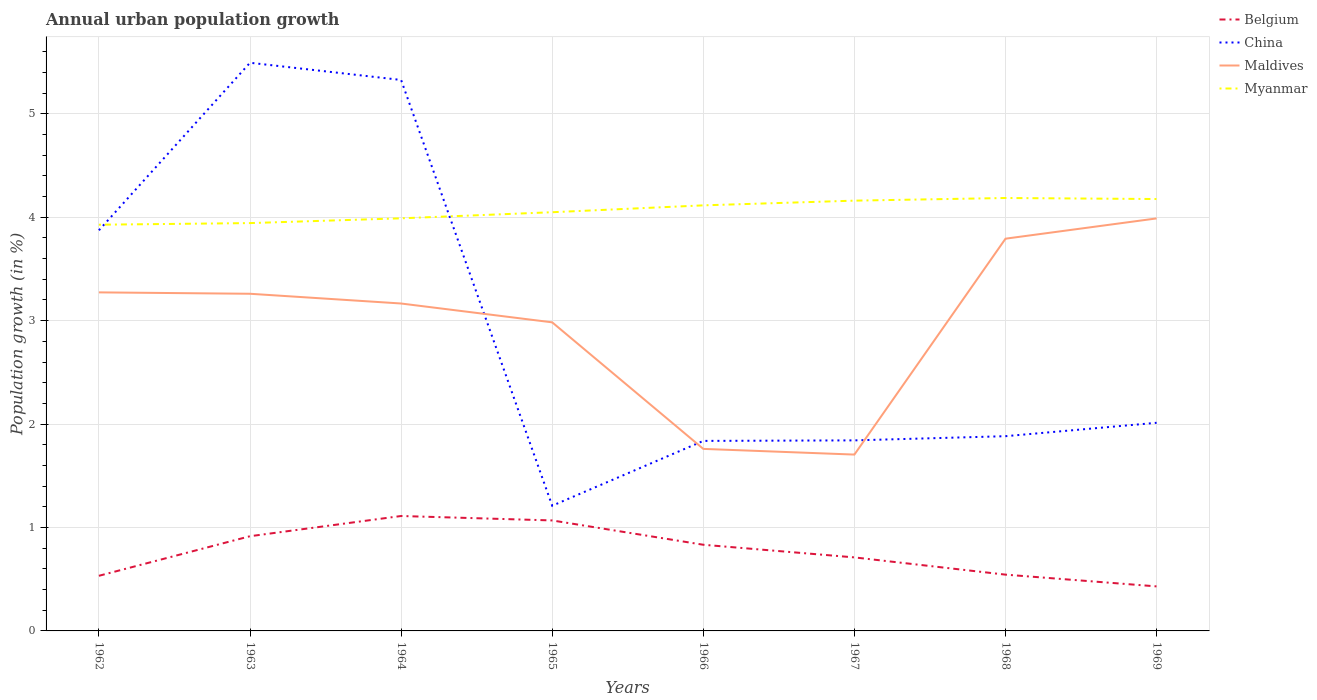Is the number of lines equal to the number of legend labels?
Keep it short and to the point. Yes. Across all years, what is the maximum percentage of urban population growth in Belgium?
Ensure brevity in your answer.  0.43. What is the total percentage of urban population growth in China in the graph?
Offer a terse response. 2.66. What is the difference between the highest and the second highest percentage of urban population growth in Belgium?
Give a very brief answer. 0.68. What is the difference between the highest and the lowest percentage of urban population growth in Belgium?
Offer a terse response. 4. How many years are there in the graph?
Make the answer very short. 8. Are the values on the major ticks of Y-axis written in scientific E-notation?
Your answer should be very brief. No. Does the graph contain any zero values?
Ensure brevity in your answer.  No. Does the graph contain grids?
Keep it short and to the point. Yes. What is the title of the graph?
Provide a succinct answer. Annual urban population growth. What is the label or title of the X-axis?
Provide a short and direct response. Years. What is the label or title of the Y-axis?
Your answer should be compact. Population growth (in %). What is the Population growth (in %) in Belgium in 1962?
Ensure brevity in your answer.  0.53. What is the Population growth (in %) of China in 1962?
Give a very brief answer. 3.87. What is the Population growth (in %) of Maldives in 1962?
Keep it short and to the point. 3.27. What is the Population growth (in %) in Myanmar in 1962?
Offer a terse response. 3.93. What is the Population growth (in %) of Belgium in 1963?
Offer a very short reply. 0.92. What is the Population growth (in %) of China in 1963?
Offer a terse response. 5.49. What is the Population growth (in %) in Maldives in 1963?
Provide a succinct answer. 3.26. What is the Population growth (in %) in Myanmar in 1963?
Your answer should be very brief. 3.94. What is the Population growth (in %) in Belgium in 1964?
Ensure brevity in your answer.  1.11. What is the Population growth (in %) of China in 1964?
Provide a short and direct response. 5.33. What is the Population growth (in %) of Maldives in 1964?
Give a very brief answer. 3.17. What is the Population growth (in %) in Myanmar in 1964?
Offer a terse response. 3.99. What is the Population growth (in %) of Belgium in 1965?
Provide a succinct answer. 1.07. What is the Population growth (in %) of China in 1965?
Provide a succinct answer. 1.21. What is the Population growth (in %) in Maldives in 1965?
Give a very brief answer. 2.98. What is the Population growth (in %) of Myanmar in 1965?
Your response must be concise. 4.05. What is the Population growth (in %) in Belgium in 1966?
Ensure brevity in your answer.  0.83. What is the Population growth (in %) of China in 1966?
Offer a very short reply. 1.84. What is the Population growth (in %) in Maldives in 1966?
Your response must be concise. 1.76. What is the Population growth (in %) of Myanmar in 1966?
Provide a short and direct response. 4.11. What is the Population growth (in %) in Belgium in 1967?
Give a very brief answer. 0.71. What is the Population growth (in %) in China in 1967?
Your response must be concise. 1.84. What is the Population growth (in %) in Maldives in 1967?
Give a very brief answer. 1.71. What is the Population growth (in %) in Myanmar in 1967?
Ensure brevity in your answer.  4.16. What is the Population growth (in %) in Belgium in 1968?
Keep it short and to the point. 0.54. What is the Population growth (in %) in China in 1968?
Give a very brief answer. 1.88. What is the Population growth (in %) of Maldives in 1968?
Make the answer very short. 3.79. What is the Population growth (in %) in Myanmar in 1968?
Give a very brief answer. 4.19. What is the Population growth (in %) in Belgium in 1969?
Offer a terse response. 0.43. What is the Population growth (in %) of China in 1969?
Provide a succinct answer. 2.01. What is the Population growth (in %) of Maldives in 1969?
Make the answer very short. 3.99. What is the Population growth (in %) in Myanmar in 1969?
Your answer should be very brief. 4.18. Across all years, what is the maximum Population growth (in %) in Belgium?
Ensure brevity in your answer.  1.11. Across all years, what is the maximum Population growth (in %) of China?
Keep it short and to the point. 5.49. Across all years, what is the maximum Population growth (in %) of Maldives?
Provide a short and direct response. 3.99. Across all years, what is the maximum Population growth (in %) in Myanmar?
Give a very brief answer. 4.19. Across all years, what is the minimum Population growth (in %) of Belgium?
Keep it short and to the point. 0.43. Across all years, what is the minimum Population growth (in %) in China?
Keep it short and to the point. 1.21. Across all years, what is the minimum Population growth (in %) in Maldives?
Your response must be concise. 1.71. Across all years, what is the minimum Population growth (in %) of Myanmar?
Offer a terse response. 3.93. What is the total Population growth (in %) of Belgium in the graph?
Your answer should be very brief. 6.15. What is the total Population growth (in %) in China in the graph?
Keep it short and to the point. 23.48. What is the total Population growth (in %) in Maldives in the graph?
Make the answer very short. 23.93. What is the total Population growth (in %) of Myanmar in the graph?
Your response must be concise. 32.55. What is the difference between the Population growth (in %) in Belgium in 1962 and that in 1963?
Offer a very short reply. -0.38. What is the difference between the Population growth (in %) of China in 1962 and that in 1963?
Offer a very short reply. -1.62. What is the difference between the Population growth (in %) of Maldives in 1962 and that in 1963?
Keep it short and to the point. 0.01. What is the difference between the Population growth (in %) in Myanmar in 1962 and that in 1963?
Provide a short and direct response. -0.02. What is the difference between the Population growth (in %) of Belgium in 1962 and that in 1964?
Provide a succinct answer. -0.58. What is the difference between the Population growth (in %) of China in 1962 and that in 1964?
Offer a very short reply. -1.45. What is the difference between the Population growth (in %) in Maldives in 1962 and that in 1964?
Your response must be concise. 0.11. What is the difference between the Population growth (in %) of Myanmar in 1962 and that in 1964?
Keep it short and to the point. -0.06. What is the difference between the Population growth (in %) of Belgium in 1962 and that in 1965?
Your answer should be compact. -0.54. What is the difference between the Population growth (in %) in China in 1962 and that in 1965?
Give a very brief answer. 2.66. What is the difference between the Population growth (in %) of Maldives in 1962 and that in 1965?
Offer a terse response. 0.29. What is the difference between the Population growth (in %) in Myanmar in 1962 and that in 1965?
Your response must be concise. -0.12. What is the difference between the Population growth (in %) in Belgium in 1962 and that in 1966?
Offer a very short reply. -0.3. What is the difference between the Population growth (in %) in China in 1962 and that in 1966?
Provide a succinct answer. 2.04. What is the difference between the Population growth (in %) in Maldives in 1962 and that in 1966?
Ensure brevity in your answer.  1.51. What is the difference between the Population growth (in %) in Myanmar in 1962 and that in 1966?
Make the answer very short. -0.19. What is the difference between the Population growth (in %) in Belgium in 1962 and that in 1967?
Offer a very short reply. -0.18. What is the difference between the Population growth (in %) in China in 1962 and that in 1967?
Give a very brief answer. 2.03. What is the difference between the Population growth (in %) in Maldives in 1962 and that in 1967?
Your answer should be compact. 1.57. What is the difference between the Population growth (in %) of Myanmar in 1962 and that in 1967?
Provide a succinct answer. -0.23. What is the difference between the Population growth (in %) of Belgium in 1962 and that in 1968?
Provide a short and direct response. -0.01. What is the difference between the Population growth (in %) of China in 1962 and that in 1968?
Your answer should be compact. 1.99. What is the difference between the Population growth (in %) in Maldives in 1962 and that in 1968?
Your answer should be very brief. -0.52. What is the difference between the Population growth (in %) of Myanmar in 1962 and that in 1968?
Your answer should be compact. -0.26. What is the difference between the Population growth (in %) of Belgium in 1962 and that in 1969?
Your response must be concise. 0.1. What is the difference between the Population growth (in %) of China in 1962 and that in 1969?
Provide a succinct answer. 1.86. What is the difference between the Population growth (in %) in Maldives in 1962 and that in 1969?
Give a very brief answer. -0.72. What is the difference between the Population growth (in %) of Myanmar in 1962 and that in 1969?
Offer a terse response. -0.25. What is the difference between the Population growth (in %) of Belgium in 1963 and that in 1964?
Make the answer very short. -0.2. What is the difference between the Population growth (in %) of China in 1963 and that in 1964?
Your response must be concise. 0.17. What is the difference between the Population growth (in %) in Maldives in 1963 and that in 1964?
Give a very brief answer. 0.09. What is the difference between the Population growth (in %) of Myanmar in 1963 and that in 1964?
Your answer should be very brief. -0.05. What is the difference between the Population growth (in %) in Belgium in 1963 and that in 1965?
Provide a short and direct response. -0.15. What is the difference between the Population growth (in %) in China in 1963 and that in 1965?
Ensure brevity in your answer.  4.28. What is the difference between the Population growth (in %) of Maldives in 1963 and that in 1965?
Ensure brevity in your answer.  0.28. What is the difference between the Population growth (in %) in Myanmar in 1963 and that in 1965?
Your answer should be very brief. -0.11. What is the difference between the Population growth (in %) in Belgium in 1963 and that in 1966?
Keep it short and to the point. 0.08. What is the difference between the Population growth (in %) of China in 1963 and that in 1966?
Your answer should be compact. 3.66. What is the difference between the Population growth (in %) in Maldives in 1963 and that in 1966?
Your response must be concise. 1.5. What is the difference between the Population growth (in %) of Myanmar in 1963 and that in 1966?
Give a very brief answer. -0.17. What is the difference between the Population growth (in %) in Belgium in 1963 and that in 1967?
Provide a short and direct response. 0.2. What is the difference between the Population growth (in %) in China in 1963 and that in 1967?
Your answer should be very brief. 3.65. What is the difference between the Population growth (in %) in Maldives in 1963 and that in 1967?
Offer a very short reply. 1.55. What is the difference between the Population growth (in %) of Myanmar in 1963 and that in 1967?
Ensure brevity in your answer.  -0.22. What is the difference between the Population growth (in %) of Belgium in 1963 and that in 1968?
Make the answer very short. 0.37. What is the difference between the Population growth (in %) in China in 1963 and that in 1968?
Your answer should be very brief. 3.61. What is the difference between the Population growth (in %) of Maldives in 1963 and that in 1968?
Your answer should be very brief. -0.53. What is the difference between the Population growth (in %) in Myanmar in 1963 and that in 1968?
Give a very brief answer. -0.24. What is the difference between the Population growth (in %) in Belgium in 1963 and that in 1969?
Provide a succinct answer. 0.49. What is the difference between the Population growth (in %) in China in 1963 and that in 1969?
Offer a terse response. 3.48. What is the difference between the Population growth (in %) of Maldives in 1963 and that in 1969?
Provide a succinct answer. -0.73. What is the difference between the Population growth (in %) of Myanmar in 1963 and that in 1969?
Provide a succinct answer. -0.23. What is the difference between the Population growth (in %) of Belgium in 1964 and that in 1965?
Offer a very short reply. 0.04. What is the difference between the Population growth (in %) in China in 1964 and that in 1965?
Provide a short and direct response. 4.12. What is the difference between the Population growth (in %) of Maldives in 1964 and that in 1965?
Your answer should be very brief. 0.18. What is the difference between the Population growth (in %) of Myanmar in 1964 and that in 1965?
Your answer should be compact. -0.06. What is the difference between the Population growth (in %) in Belgium in 1964 and that in 1966?
Your answer should be compact. 0.28. What is the difference between the Population growth (in %) of China in 1964 and that in 1966?
Give a very brief answer. 3.49. What is the difference between the Population growth (in %) of Maldives in 1964 and that in 1966?
Your answer should be compact. 1.41. What is the difference between the Population growth (in %) of Myanmar in 1964 and that in 1966?
Your response must be concise. -0.13. What is the difference between the Population growth (in %) in Belgium in 1964 and that in 1967?
Offer a very short reply. 0.4. What is the difference between the Population growth (in %) of China in 1964 and that in 1967?
Provide a succinct answer. 3.48. What is the difference between the Population growth (in %) of Maldives in 1964 and that in 1967?
Provide a succinct answer. 1.46. What is the difference between the Population growth (in %) in Myanmar in 1964 and that in 1967?
Keep it short and to the point. -0.17. What is the difference between the Population growth (in %) of Belgium in 1964 and that in 1968?
Offer a very short reply. 0.57. What is the difference between the Population growth (in %) in China in 1964 and that in 1968?
Offer a terse response. 3.44. What is the difference between the Population growth (in %) of Maldives in 1964 and that in 1968?
Your answer should be compact. -0.63. What is the difference between the Population growth (in %) of Myanmar in 1964 and that in 1968?
Provide a succinct answer. -0.2. What is the difference between the Population growth (in %) of Belgium in 1964 and that in 1969?
Provide a succinct answer. 0.68. What is the difference between the Population growth (in %) of China in 1964 and that in 1969?
Your answer should be very brief. 3.31. What is the difference between the Population growth (in %) in Maldives in 1964 and that in 1969?
Offer a very short reply. -0.82. What is the difference between the Population growth (in %) of Myanmar in 1964 and that in 1969?
Your answer should be very brief. -0.19. What is the difference between the Population growth (in %) of Belgium in 1965 and that in 1966?
Your response must be concise. 0.24. What is the difference between the Population growth (in %) in China in 1965 and that in 1966?
Make the answer very short. -0.63. What is the difference between the Population growth (in %) of Maldives in 1965 and that in 1966?
Provide a short and direct response. 1.22. What is the difference between the Population growth (in %) in Myanmar in 1965 and that in 1966?
Provide a succinct answer. -0.07. What is the difference between the Population growth (in %) of Belgium in 1965 and that in 1967?
Provide a succinct answer. 0.36. What is the difference between the Population growth (in %) in China in 1965 and that in 1967?
Your answer should be compact. -0.63. What is the difference between the Population growth (in %) in Maldives in 1965 and that in 1967?
Offer a terse response. 1.28. What is the difference between the Population growth (in %) of Myanmar in 1965 and that in 1967?
Your answer should be very brief. -0.11. What is the difference between the Population growth (in %) in Belgium in 1965 and that in 1968?
Ensure brevity in your answer.  0.52. What is the difference between the Population growth (in %) of China in 1965 and that in 1968?
Make the answer very short. -0.67. What is the difference between the Population growth (in %) in Maldives in 1965 and that in 1968?
Provide a short and direct response. -0.81. What is the difference between the Population growth (in %) in Myanmar in 1965 and that in 1968?
Make the answer very short. -0.14. What is the difference between the Population growth (in %) in Belgium in 1965 and that in 1969?
Provide a succinct answer. 0.64. What is the difference between the Population growth (in %) in China in 1965 and that in 1969?
Give a very brief answer. -0.8. What is the difference between the Population growth (in %) of Maldives in 1965 and that in 1969?
Your answer should be very brief. -1. What is the difference between the Population growth (in %) of Myanmar in 1965 and that in 1969?
Your response must be concise. -0.13. What is the difference between the Population growth (in %) of Belgium in 1966 and that in 1967?
Keep it short and to the point. 0.12. What is the difference between the Population growth (in %) of China in 1966 and that in 1967?
Offer a very short reply. -0.01. What is the difference between the Population growth (in %) in Maldives in 1966 and that in 1967?
Ensure brevity in your answer.  0.06. What is the difference between the Population growth (in %) of Myanmar in 1966 and that in 1967?
Your answer should be compact. -0.05. What is the difference between the Population growth (in %) in Belgium in 1966 and that in 1968?
Give a very brief answer. 0.29. What is the difference between the Population growth (in %) in China in 1966 and that in 1968?
Provide a succinct answer. -0.05. What is the difference between the Population growth (in %) in Maldives in 1966 and that in 1968?
Your answer should be compact. -2.03. What is the difference between the Population growth (in %) of Myanmar in 1966 and that in 1968?
Offer a very short reply. -0.07. What is the difference between the Population growth (in %) in Belgium in 1966 and that in 1969?
Your answer should be very brief. 0.4. What is the difference between the Population growth (in %) in China in 1966 and that in 1969?
Make the answer very short. -0.17. What is the difference between the Population growth (in %) in Maldives in 1966 and that in 1969?
Ensure brevity in your answer.  -2.23. What is the difference between the Population growth (in %) of Myanmar in 1966 and that in 1969?
Offer a terse response. -0.06. What is the difference between the Population growth (in %) of China in 1967 and that in 1968?
Provide a short and direct response. -0.04. What is the difference between the Population growth (in %) of Maldives in 1967 and that in 1968?
Make the answer very short. -2.09. What is the difference between the Population growth (in %) in Myanmar in 1967 and that in 1968?
Offer a very short reply. -0.03. What is the difference between the Population growth (in %) in Belgium in 1967 and that in 1969?
Keep it short and to the point. 0.28. What is the difference between the Population growth (in %) of China in 1967 and that in 1969?
Keep it short and to the point. -0.17. What is the difference between the Population growth (in %) of Maldives in 1967 and that in 1969?
Make the answer very short. -2.28. What is the difference between the Population growth (in %) in Myanmar in 1967 and that in 1969?
Provide a succinct answer. -0.02. What is the difference between the Population growth (in %) of Belgium in 1968 and that in 1969?
Your answer should be compact. 0.11. What is the difference between the Population growth (in %) of China in 1968 and that in 1969?
Your response must be concise. -0.13. What is the difference between the Population growth (in %) of Maldives in 1968 and that in 1969?
Your response must be concise. -0.2. What is the difference between the Population growth (in %) of Belgium in 1962 and the Population growth (in %) of China in 1963?
Give a very brief answer. -4.96. What is the difference between the Population growth (in %) in Belgium in 1962 and the Population growth (in %) in Maldives in 1963?
Give a very brief answer. -2.73. What is the difference between the Population growth (in %) of Belgium in 1962 and the Population growth (in %) of Myanmar in 1963?
Your answer should be compact. -3.41. What is the difference between the Population growth (in %) in China in 1962 and the Population growth (in %) in Maldives in 1963?
Keep it short and to the point. 0.61. What is the difference between the Population growth (in %) in China in 1962 and the Population growth (in %) in Myanmar in 1963?
Your response must be concise. -0.07. What is the difference between the Population growth (in %) of Maldives in 1962 and the Population growth (in %) of Myanmar in 1963?
Your answer should be compact. -0.67. What is the difference between the Population growth (in %) of Belgium in 1962 and the Population growth (in %) of China in 1964?
Keep it short and to the point. -4.79. What is the difference between the Population growth (in %) in Belgium in 1962 and the Population growth (in %) in Maldives in 1964?
Keep it short and to the point. -2.63. What is the difference between the Population growth (in %) in Belgium in 1962 and the Population growth (in %) in Myanmar in 1964?
Offer a terse response. -3.46. What is the difference between the Population growth (in %) in China in 1962 and the Population growth (in %) in Maldives in 1964?
Offer a very short reply. 0.71. What is the difference between the Population growth (in %) of China in 1962 and the Population growth (in %) of Myanmar in 1964?
Your response must be concise. -0.12. What is the difference between the Population growth (in %) in Maldives in 1962 and the Population growth (in %) in Myanmar in 1964?
Give a very brief answer. -0.72. What is the difference between the Population growth (in %) of Belgium in 1962 and the Population growth (in %) of China in 1965?
Your answer should be very brief. -0.68. What is the difference between the Population growth (in %) of Belgium in 1962 and the Population growth (in %) of Maldives in 1965?
Keep it short and to the point. -2.45. What is the difference between the Population growth (in %) of Belgium in 1962 and the Population growth (in %) of Myanmar in 1965?
Your answer should be very brief. -3.52. What is the difference between the Population growth (in %) of China in 1962 and the Population growth (in %) of Maldives in 1965?
Provide a succinct answer. 0.89. What is the difference between the Population growth (in %) of China in 1962 and the Population growth (in %) of Myanmar in 1965?
Give a very brief answer. -0.17. What is the difference between the Population growth (in %) of Maldives in 1962 and the Population growth (in %) of Myanmar in 1965?
Offer a very short reply. -0.78. What is the difference between the Population growth (in %) in Belgium in 1962 and the Population growth (in %) in China in 1966?
Offer a terse response. -1.3. What is the difference between the Population growth (in %) of Belgium in 1962 and the Population growth (in %) of Maldives in 1966?
Offer a very short reply. -1.23. What is the difference between the Population growth (in %) of Belgium in 1962 and the Population growth (in %) of Myanmar in 1966?
Your answer should be compact. -3.58. What is the difference between the Population growth (in %) in China in 1962 and the Population growth (in %) in Maldives in 1966?
Offer a terse response. 2.11. What is the difference between the Population growth (in %) of China in 1962 and the Population growth (in %) of Myanmar in 1966?
Give a very brief answer. -0.24. What is the difference between the Population growth (in %) of Maldives in 1962 and the Population growth (in %) of Myanmar in 1966?
Keep it short and to the point. -0.84. What is the difference between the Population growth (in %) of Belgium in 1962 and the Population growth (in %) of China in 1967?
Offer a terse response. -1.31. What is the difference between the Population growth (in %) of Belgium in 1962 and the Population growth (in %) of Maldives in 1967?
Give a very brief answer. -1.17. What is the difference between the Population growth (in %) in Belgium in 1962 and the Population growth (in %) in Myanmar in 1967?
Your answer should be compact. -3.63. What is the difference between the Population growth (in %) of China in 1962 and the Population growth (in %) of Maldives in 1967?
Offer a terse response. 2.17. What is the difference between the Population growth (in %) of China in 1962 and the Population growth (in %) of Myanmar in 1967?
Your answer should be very brief. -0.29. What is the difference between the Population growth (in %) in Maldives in 1962 and the Population growth (in %) in Myanmar in 1967?
Offer a very short reply. -0.89. What is the difference between the Population growth (in %) of Belgium in 1962 and the Population growth (in %) of China in 1968?
Keep it short and to the point. -1.35. What is the difference between the Population growth (in %) of Belgium in 1962 and the Population growth (in %) of Maldives in 1968?
Ensure brevity in your answer.  -3.26. What is the difference between the Population growth (in %) in Belgium in 1962 and the Population growth (in %) in Myanmar in 1968?
Offer a very short reply. -3.65. What is the difference between the Population growth (in %) of China in 1962 and the Population growth (in %) of Maldives in 1968?
Give a very brief answer. 0.08. What is the difference between the Population growth (in %) of China in 1962 and the Population growth (in %) of Myanmar in 1968?
Provide a succinct answer. -0.31. What is the difference between the Population growth (in %) of Maldives in 1962 and the Population growth (in %) of Myanmar in 1968?
Offer a terse response. -0.91. What is the difference between the Population growth (in %) in Belgium in 1962 and the Population growth (in %) in China in 1969?
Offer a terse response. -1.48. What is the difference between the Population growth (in %) of Belgium in 1962 and the Population growth (in %) of Maldives in 1969?
Give a very brief answer. -3.46. What is the difference between the Population growth (in %) in Belgium in 1962 and the Population growth (in %) in Myanmar in 1969?
Your response must be concise. -3.64. What is the difference between the Population growth (in %) in China in 1962 and the Population growth (in %) in Maldives in 1969?
Give a very brief answer. -0.11. What is the difference between the Population growth (in %) of China in 1962 and the Population growth (in %) of Myanmar in 1969?
Make the answer very short. -0.3. What is the difference between the Population growth (in %) of Maldives in 1962 and the Population growth (in %) of Myanmar in 1969?
Offer a terse response. -0.9. What is the difference between the Population growth (in %) in Belgium in 1963 and the Population growth (in %) in China in 1964?
Offer a very short reply. -4.41. What is the difference between the Population growth (in %) of Belgium in 1963 and the Population growth (in %) of Maldives in 1964?
Provide a short and direct response. -2.25. What is the difference between the Population growth (in %) in Belgium in 1963 and the Population growth (in %) in Myanmar in 1964?
Provide a short and direct response. -3.07. What is the difference between the Population growth (in %) in China in 1963 and the Population growth (in %) in Maldives in 1964?
Make the answer very short. 2.33. What is the difference between the Population growth (in %) in China in 1963 and the Population growth (in %) in Myanmar in 1964?
Give a very brief answer. 1.5. What is the difference between the Population growth (in %) in Maldives in 1963 and the Population growth (in %) in Myanmar in 1964?
Provide a succinct answer. -0.73. What is the difference between the Population growth (in %) in Belgium in 1963 and the Population growth (in %) in China in 1965?
Give a very brief answer. -0.29. What is the difference between the Population growth (in %) of Belgium in 1963 and the Population growth (in %) of Maldives in 1965?
Provide a succinct answer. -2.07. What is the difference between the Population growth (in %) in Belgium in 1963 and the Population growth (in %) in Myanmar in 1965?
Offer a very short reply. -3.13. What is the difference between the Population growth (in %) in China in 1963 and the Population growth (in %) in Maldives in 1965?
Make the answer very short. 2.51. What is the difference between the Population growth (in %) in China in 1963 and the Population growth (in %) in Myanmar in 1965?
Your answer should be compact. 1.45. What is the difference between the Population growth (in %) in Maldives in 1963 and the Population growth (in %) in Myanmar in 1965?
Your answer should be very brief. -0.79. What is the difference between the Population growth (in %) in Belgium in 1963 and the Population growth (in %) in China in 1966?
Provide a succinct answer. -0.92. What is the difference between the Population growth (in %) in Belgium in 1963 and the Population growth (in %) in Maldives in 1966?
Your answer should be very brief. -0.84. What is the difference between the Population growth (in %) of Belgium in 1963 and the Population growth (in %) of Myanmar in 1966?
Give a very brief answer. -3.2. What is the difference between the Population growth (in %) in China in 1963 and the Population growth (in %) in Maldives in 1966?
Keep it short and to the point. 3.73. What is the difference between the Population growth (in %) of China in 1963 and the Population growth (in %) of Myanmar in 1966?
Ensure brevity in your answer.  1.38. What is the difference between the Population growth (in %) of Maldives in 1963 and the Population growth (in %) of Myanmar in 1966?
Make the answer very short. -0.85. What is the difference between the Population growth (in %) in Belgium in 1963 and the Population growth (in %) in China in 1967?
Give a very brief answer. -0.93. What is the difference between the Population growth (in %) of Belgium in 1963 and the Population growth (in %) of Maldives in 1967?
Your answer should be very brief. -0.79. What is the difference between the Population growth (in %) of Belgium in 1963 and the Population growth (in %) of Myanmar in 1967?
Your response must be concise. -3.24. What is the difference between the Population growth (in %) of China in 1963 and the Population growth (in %) of Maldives in 1967?
Offer a terse response. 3.79. What is the difference between the Population growth (in %) in China in 1963 and the Population growth (in %) in Myanmar in 1967?
Your answer should be compact. 1.33. What is the difference between the Population growth (in %) of Maldives in 1963 and the Population growth (in %) of Myanmar in 1967?
Your answer should be compact. -0.9. What is the difference between the Population growth (in %) in Belgium in 1963 and the Population growth (in %) in China in 1968?
Your response must be concise. -0.97. What is the difference between the Population growth (in %) in Belgium in 1963 and the Population growth (in %) in Maldives in 1968?
Your answer should be very brief. -2.88. What is the difference between the Population growth (in %) of Belgium in 1963 and the Population growth (in %) of Myanmar in 1968?
Your answer should be compact. -3.27. What is the difference between the Population growth (in %) in China in 1963 and the Population growth (in %) in Maldives in 1968?
Your answer should be compact. 1.7. What is the difference between the Population growth (in %) of China in 1963 and the Population growth (in %) of Myanmar in 1968?
Keep it short and to the point. 1.31. What is the difference between the Population growth (in %) in Maldives in 1963 and the Population growth (in %) in Myanmar in 1968?
Make the answer very short. -0.93. What is the difference between the Population growth (in %) in Belgium in 1963 and the Population growth (in %) in China in 1969?
Give a very brief answer. -1.1. What is the difference between the Population growth (in %) in Belgium in 1963 and the Population growth (in %) in Maldives in 1969?
Provide a short and direct response. -3.07. What is the difference between the Population growth (in %) in Belgium in 1963 and the Population growth (in %) in Myanmar in 1969?
Keep it short and to the point. -3.26. What is the difference between the Population growth (in %) in China in 1963 and the Population growth (in %) in Maldives in 1969?
Offer a terse response. 1.5. What is the difference between the Population growth (in %) in China in 1963 and the Population growth (in %) in Myanmar in 1969?
Offer a terse response. 1.32. What is the difference between the Population growth (in %) in Maldives in 1963 and the Population growth (in %) in Myanmar in 1969?
Your response must be concise. -0.92. What is the difference between the Population growth (in %) of Belgium in 1964 and the Population growth (in %) of China in 1965?
Make the answer very short. -0.1. What is the difference between the Population growth (in %) in Belgium in 1964 and the Population growth (in %) in Maldives in 1965?
Offer a very short reply. -1.87. What is the difference between the Population growth (in %) of Belgium in 1964 and the Population growth (in %) of Myanmar in 1965?
Make the answer very short. -2.94. What is the difference between the Population growth (in %) in China in 1964 and the Population growth (in %) in Maldives in 1965?
Provide a succinct answer. 2.34. What is the difference between the Population growth (in %) in China in 1964 and the Population growth (in %) in Myanmar in 1965?
Keep it short and to the point. 1.28. What is the difference between the Population growth (in %) in Maldives in 1964 and the Population growth (in %) in Myanmar in 1965?
Keep it short and to the point. -0.88. What is the difference between the Population growth (in %) of Belgium in 1964 and the Population growth (in %) of China in 1966?
Offer a very short reply. -0.73. What is the difference between the Population growth (in %) of Belgium in 1964 and the Population growth (in %) of Maldives in 1966?
Make the answer very short. -0.65. What is the difference between the Population growth (in %) in Belgium in 1964 and the Population growth (in %) in Myanmar in 1966?
Provide a short and direct response. -3. What is the difference between the Population growth (in %) of China in 1964 and the Population growth (in %) of Maldives in 1966?
Provide a short and direct response. 3.57. What is the difference between the Population growth (in %) of China in 1964 and the Population growth (in %) of Myanmar in 1966?
Your answer should be very brief. 1.21. What is the difference between the Population growth (in %) of Maldives in 1964 and the Population growth (in %) of Myanmar in 1966?
Provide a short and direct response. -0.95. What is the difference between the Population growth (in %) of Belgium in 1964 and the Population growth (in %) of China in 1967?
Give a very brief answer. -0.73. What is the difference between the Population growth (in %) of Belgium in 1964 and the Population growth (in %) of Maldives in 1967?
Ensure brevity in your answer.  -0.59. What is the difference between the Population growth (in %) in Belgium in 1964 and the Population growth (in %) in Myanmar in 1967?
Provide a succinct answer. -3.05. What is the difference between the Population growth (in %) of China in 1964 and the Population growth (in %) of Maldives in 1967?
Provide a succinct answer. 3.62. What is the difference between the Population growth (in %) of China in 1964 and the Population growth (in %) of Myanmar in 1967?
Ensure brevity in your answer.  1.17. What is the difference between the Population growth (in %) in Maldives in 1964 and the Population growth (in %) in Myanmar in 1967?
Keep it short and to the point. -0.99. What is the difference between the Population growth (in %) of Belgium in 1964 and the Population growth (in %) of China in 1968?
Ensure brevity in your answer.  -0.77. What is the difference between the Population growth (in %) in Belgium in 1964 and the Population growth (in %) in Maldives in 1968?
Offer a very short reply. -2.68. What is the difference between the Population growth (in %) of Belgium in 1964 and the Population growth (in %) of Myanmar in 1968?
Provide a short and direct response. -3.07. What is the difference between the Population growth (in %) of China in 1964 and the Population growth (in %) of Maldives in 1968?
Your answer should be compact. 1.53. What is the difference between the Population growth (in %) of China in 1964 and the Population growth (in %) of Myanmar in 1968?
Give a very brief answer. 1.14. What is the difference between the Population growth (in %) in Maldives in 1964 and the Population growth (in %) in Myanmar in 1968?
Offer a terse response. -1.02. What is the difference between the Population growth (in %) of Belgium in 1964 and the Population growth (in %) of China in 1969?
Your answer should be very brief. -0.9. What is the difference between the Population growth (in %) of Belgium in 1964 and the Population growth (in %) of Maldives in 1969?
Give a very brief answer. -2.88. What is the difference between the Population growth (in %) in Belgium in 1964 and the Population growth (in %) in Myanmar in 1969?
Keep it short and to the point. -3.06. What is the difference between the Population growth (in %) in China in 1964 and the Population growth (in %) in Maldives in 1969?
Ensure brevity in your answer.  1.34. What is the difference between the Population growth (in %) in China in 1964 and the Population growth (in %) in Myanmar in 1969?
Provide a succinct answer. 1.15. What is the difference between the Population growth (in %) in Maldives in 1964 and the Population growth (in %) in Myanmar in 1969?
Offer a terse response. -1.01. What is the difference between the Population growth (in %) of Belgium in 1965 and the Population growth (in %) of China in 1966?
Provide a short and direct response. -0.77. What is the difference between the Population growth (in %) in Belgium in 1965 and the Population growth (in %) in Maldives in 1966?
Offer a terse response. -0.69. What is the difference between the Population growth (in %) of Belgium in 1965 and the Population growth (in %) of Myanmar in 1966?
Offer a very short reply. -3.05. What is the difference between the Population growth (in %) of China in 1965 and the Population growth (in %) of Maldives in 1966?
Offer a very short reply. -0.55. What is the difference between the Population growth (in %) in China in 1965 and the Population growth (in %) in Myanmar in 1966?
Give a very brief answer. -2.9. What is the difference between the Population growth (in %) of Maldives in 1965 and the Population growth (in %) of Myanmar in 1966?
Give a very brief answer. -1.13. What is the difference between the Population growth (in %) of Belgium in 1965 and the Population growth (in %) of China in 1967?
Provide a short and direct response. -0.77. What is the difference between the Population growth (in %) of Belgium in 1965 and the Population growth (in %) of Maldives in 1967?
Give a very brief answer. -0.64. What is the difference between the Population growth (in %) of Belgium in 1965 and the Population growth (in %) of Myanmar in 1967?
Give a very brief answer. -3.09. What is the difference between the Population growth (in %) of China in 1965 and the Population growth (in %) of Maldives in 1967?
Your answer should be compact. -0.49. What is the difference between the Population growth (in %) in China in 1965 and the Population growth (in %) in Myanmar in 1967?
Keep it short and to the point. -2.95. What is the difference between the Population growth (in %) of Maldives in 1965 and the Population growth (in %) of Myanmar in 1967?
Provide a short and direct response. -1.18. What is the difference between the Population growth (in %) of Belgium in 1965 and the Population growth (in %) of China in 1968?
Your answer should be compact. -0.81. What is the difference between the Population growth (in %) in Belgium in 1965 and the Population growth (in %) in Maldives in 1968?
Offer a very short reply. -2.72. What is the difference between the Population growth (in %) in Belgium in 1965 and the Population growth (in %) in Myanmar in 1968?
Your answer should be compact. -3.12. What is the difference between the Population growth (in %) in China in 1965 and the Population growth (in %) in Maldives in 1968?
Your answer should be compact. -2.58. What is the difference between the Population growth (in %) in China in 1965 and the Population growth (in %) in Myanmar in 1968?
Your response must be concise. -2.98. What is the difference between the Population growth (in %) in Maldives in 1965 and the Population growth (in %) in Myanmar in 1968?
Ensure brevity in your answer.  -1.2. What is the difference between the Population growth (in %) of Belgium in 1965 and the Population growth (in %) of China in 1969?
Ensure brevity in your answer.  -0.94. What is the difference between the Population growth (in %) of Belgium in 1965 and the Population growth (in %) of Maldives in 1969?
Provide a succinct answer. -2.92. What is the difference between the Population growth (in %) in Belgium in 1965 and the Population growth (in %) in Myanmar in 1969?
Ensure brevity in your answer.  -3.11. What is the difference between the Population growth (in %) in China in 1965 and the Population growth (in %) in Maldives in 1969?
Offer a very short reply. -2.78. What is the difference between the Population growth (in %) in China in 1965 and the Population growth (in %) in Myanmar in 1969?
Provide a short and direct response. -2.97. What is the difference between the Population growth (in %) of Maldives in 1965 and the Population growth (in %) of Myanmar in 1969?
Offer a terse response. -1.19. What is the difference between the Population growth (in %) in Belgium in 1966 and the Population growth (in %) in China in 1967?
Your response must be concise. -1.01. What is the difference between the Population growth (in %) in Belgium in 1966 and the Population growth (in %) in Maldives in 1967?
Offer a terse response. -0.87. What is the difference between the Population growth (in %) of Belgium in 1966 and the Population growth (in %) of Myanmar in 1967?
Make the answer very short. -3.33. What is the difference between the Population growth (in %) in China in 1966 and the Population growth (in %) in Maldives in 1967?
Give a very brief answer. 0.13. What is the difference between the Population growth (in %) of China in 1966 and the Population growth (in %) of Myanmar in 1967?
Offer a very short reply. -2.32. What is the difference between the Population growth (in %) in Maldives in 1966 and the Population growth (in %) in Myanmar in 1967?
Provide a short and direct response. -2.4. What is the difference between the Population growth (in %) in Belgium in 1966 and the Population growth (in %) in China in 1968?
Ensure brevity in your answer.  -1.05. What is the difference between the Population growth (in %) of Belgium in 1966 and the Population growth (in %) of Maldives in 1968?
Offer a very short reply. -2.96. What is the difference between the Population growth (in %) in Belgium in 1966 and the Population growth (in %) in Myanmar in 1968?
Provide a short and direct response. -3.35. What is the difference between the Population growth (in %) in China in 1966 and the Population growth (in %) in Maldives in 1968?
Your response must be concise. -1.96. What is the difference between the Population growth (in %) in China in 1966 and the Population growth (in %) in Myanmar in 1968?
Provide a short and direct response. -2.35. What is the difference between the Population growth (in %) in Maldives in 1966 and the Population growth (in %) in Myanmar in 1968?
Offer a terse response. -2.43. What is the difference between the Population growth (in %) of Belgium in 1966 and the Population growth (in %) of China in 1969?
Your response must be concise. -1.18. What is the difference between the Population growth (in %) of Belgium in 1966 and the Population growth (in %) of Maldives in 1969?
Your response must be concise. -3.16. What is the difference between the Population growth (in %) in Belgium in 1966 and the Population growth (in %) in Myanmar in 1969?
Provide a short and direct response. -3.34. What is the difference between the Population growth (in %) of China in 1966 and the Population growth (in %) of Maldives in 1969?
Give a very brief answer. -2.15. What is the difference between the Population growth (in %) of China in 1966 and the Population growth (in %) of Myanmar in 1969?
Provide a succinct answer. -2.34. What is the difference between the Population growth (in %) in Maldives in 1966 and the Population growth (in %) in Myanmar in 1969?
Provide a succinct answer. -2.42. What is the difference between the Population growth (in %) in Belgium in 1967 and the Population growth (in %) in China in 1968?
Offer a terse response. -1.17. What is the difference between the Population growth (in %) of Belgium in 1967 and the Population growth (in %) of Maldives in 1968?
Provide a short and direct response. -3.08. What is the difference between the Population growth (in %) of Belgium in 1967 and the Population growth (in %) of Myanmar in 1968?
Ensure brevity in your answer.  -3.48. What is the difference between the Population growth (in %) of China in 1967 and the Population growth (in %) of Maldives in 1968?
Ensure brevity in your answer.  -1.95. What is the difference between the Population growth (in %) of China in 1967 and the Population growth (in %) of Myanmar in 1968?
Ensure brevity in your answer.  -2.34. What is the difference between the Population growth (in %) in Maldives in 1967 and the Population growth (in %) in Myanmar in 1968?
Give a very brief answer. -2.48. What is the difference between the Population growth (in %) in Belgium in 1967 and the Population growth (in %) in China in 1969?
Ensure brevity in your answer.  -1.3. What is the difference between the Population growth (in %) in Belgium in 1967 and the Population growth (in %) in Maldives in 1969?
Your response must be concise. -3.28. What is the difference between the Population growth (in %) in Belgium in 1967 and the Population growth (in %) in Myanmar in 1969?
Offer a very short reply. -3.47. What is the difference between the Population growth (in %) in China in 1967 and the Population growth (in %) in Maldives in 1969?
Provide a short and direct response. -2.15. What is the difference between the Population growth (in %) of China in 1967 and the Population growth (in %) of Myanmar in 1969?
Provide a short and direct response. -2.33. What is the difference between the Population growth (in %) in Maldives in 1967 and the Population growth (in %) in Myanmar in 1969?
Your response must be concise. -2.47. What is the difference between the Population growth (in %) of Belgium in 1968 and the Population growth (in %) of China in 1969?
Your response must be concise. -1.47. What is the difference between the Population growth (in %) in Belgium in 1968 and the Population growth (in %) in Maldives in 1969?
Provide a succinct answer. -3.44. What is the difference between the Population growth (in %) of Belgium in 1968 and the Population growth (in %) of Myanmar in 1969?
Offer a terse response. -3.63. What is the difference between the Population growth (in %) of China in 1968 and the Population growth (in %) of Maldives in 1969?
Make the answer very short. -2.11. What is the difference between the Population growth (in %) in China in 1968 and the Population growth (in %) in Myanmar in 1969?
Offer a terse response. -2.29. What is the difference between the Population growth (in %) of Maldives in 1968 and the Population growth (in %) of Myanmar in 1969?
Your answer should be compact. -0.38. What is the average Population growth (in %) of Belgium per year?
Give a very brief answer. 0.77. What is the average Population growth (in %) of China per year?
Give a very brief answer. 2.94. What is the average Population growth (in %) of Maldives per year?
Give a very brief answer. 2.99. What is the average Population growth (in %) of Myanmar per year?
Provide a succinct answer. 4.07. In the year 1962, what is the difference between the Population growth (in %) in Belgium and Population growth (in %) in China?
Your answer should be compact. -3.34. In the year 1962, what is the difference between the Population growth (in %) of Belgium and Population growth (in %) of Maldives?
Give a very brief answer. -2.74. In the year 1962, what is the difference between the Population growth (in %) of Belgium and Population growth (in %) of Myanmar?
Keep it short and to the point. -3.39. In the year 1962, what is the difference between the Population growth (in %) of China and Population growth (in %) of Maldives?
Your response must be concise. 0.6. In the year 1962, what is the difference between the Population growth (in %) in China and Population growth (in %) in Myanmar?
Your response must be concise. -0.05. In the year 1962, what is the difference between the Population growth (in %) in Maldives and Population growth (in %) in Myanmar?
Offer a terse response. -0.65. In the year 1963, what is the difference between the Population growth (in %) in Belgium and Population growth (in %) in China?
Your response must be concise. -4.58. In the year 1963, what is the difference between the Population growth (in %) of Belgium and Population growth (in %) of Maldives?
Keep it short and to the point. -2.34. In the year 1963, what is the difference between the Population growth (in %) of Belgium and Population growth (in %) of Myanmar?
Your answer should be compact. -3.03. In the year 1963, what is the difference between the Population growth (in %) in China and Population growth (in %) in Maldives?
Your answer should be compact. 2.23. In the year 1963, what is the difference between the Population growth (in %) of China and Population growth (in %) of Myanmar?
Provide a succinct answer. 1.55. In the year 1963, what is the difference between the Population growth (in %) in Maldives and Population growth (in %) in Myanmar?
Ensure brevity in your answer.  -0.68. In the year 1964, what is the difference between the Population growth (in %) of Belgium and Population growth (in %) of China?
Make the answer very short. -4.22. In the year 1964, what is the difference between the Population growth (in %) of Belgium and Population growth (in %) of Maldives?
Provide a succinct answer. -2.05. In the year 1964, what is the difference between the Population growth (in %) in Belgium and Population growth (in %) in Myanmar?
Your answer should be compact. -2.88. In the year 1964, what is the difference between the Population growth (in %) of China and Population growth (in %) of Maldives?
Make the answer very short. 2.16. In the year 1964, what is the difference between the Population growth (in %) in China and Population growth (in %) in Myanmar?
Your response must be concise. 1.34. In the year 1964, what is the difference between the Population growth (in %) in Maldives and Population growth (in %) in Myanmar?
Give a very brief answer. -0.82. In the year 1965, what is the difference between the Population growth (in %) of Belgium and Population growth (in %) of China?
Your response must be concise. -0.14. In the year 1965, what is the difference between the Population growth (in %) in Belgium and Population growth (in %) in Maldives?
Your answer should be compact. -1.92. In the year 1965, what is the difference between the Population growth (in %) of Belgium and Population growth (in %) of Myanmar?
Keep it short and to the point. -2.98. In the year 1965, what is the difference between the Population growth (in %) of China and Population growth (in %) of Maldives?
Offer a terse response. -1.77. In the year 1965, what is the difference between the Population growth (in %) of China and Population growth (in %) of Myanmar?
Make the answer very short. -2.84. In the year 1965, what is the difference between the Population growth (in %) in Maldives and Population growth (in %) in Myanmar?
Provide a succinct answer. -1.06. In the year 1966, what is the difference between the Population growth (in %) of Belgium and Population growth (in %) of China?
Provide a succinct answer. -1. In the year 1966, what is the difference between the Population growth (in %) in Belgium and Population growth (in %) in Maldives?
Your response must be concise. -0.93. In the year 1966, what is the difference between the Population growth (in %) of Belgium and Population growth (in %) of Myanmar?
Your response must be concise. -3.28. In the year 1966, what is the difference between the Population growth (in %) in China and Population growth (in %) in Maldives?
Your answer should be very brief. 0.08. In the year 1966, what is the difference between the Population growth (in %) of China and Population growth (in %) of Myanmar?
Provide a succinct answer. -2.28. In the year 1966, what is the difference between the Population growth (in %) of Maldives and Population growth (in %) of Myanmar?
Ensure brevity in your answer.  -2.35. In the year 1967, what is the difference between the Population growth (in %) in Belgium and Population growth (in %) in China?
Give a very brief answer. -1.13. In the year 1967, what is the difference between the Population growth (in %) in Belgium and Population growth (in %) in Maldives?
Your response must be concise. -0.99. In the year 1967, what is the difference between the Population growth (in %) of Belgium and Population growth (in %) of Myanmar?
Ensure brevity in your answer.  -3.45. In the year 1967, what is the difference between the Population growth (in %) of China and Population growth (in %) of Maldives?
Your answer should be very brief. 0.14. In the year 1967, what is the difference between the Population growth (in %) of China and Population growth (in %) of Myanmar?
Offer a very short reply. -2.32. In the year 1967, what is the difference between the Population growth (in %) in Maldives and Population growth (in %) in Myanmar?
Your answer should be very brief. -2.46. In the year 1968, what is the difference between the Population growth (in %) of Belgium and Population growth (in %) of China?
Offer a very short reply. -1.34. In the year 1968, what is the difference between the Population growth (in %) of Belgium and Population growth (in %) of Maldives?
Give a very brief answer. -3.25. In the year 1968, what is the difference between the Population growth (in %) in Belgium and Population growth (in %) in Myanmar?
Provide a succinct answer. -3.64. In the year 1968, what is the difference between the Population growth (in %) of China and Population growth (in %) of Maldives?
Your answer should be very brief. -1.91. In the year 1968, what is the difference between the Population growth (in %) of China and Population growth (in %) of Myanmar?
Give a very brief answer. -2.3. In the year 1968, what is the difference between the Population growth (in %) of Maldives and Population growth (in %) of Myanmar?
Provide a succinct answer. -0.39. In the year 1969, what is the difference between the Population growth (in %) of Belgium and Population growth (in %) of China?
Give a very brief answer. -1.58. In the year 1969, what is the difference between the Population growth (in %) in Belgium and Population growth (in %) in Maldives?
Keep it short and to the point. -3.56. In the year 1969, what is the difference between the Population growth (in %) in Belgium and Population growth (in %) in Myanmar?
Provide a short and direct response. -3.75. In the year 1969, what is the difference between the Population growth (in %) of China and Population growth (in %) of Maldives?
Make the answer very short. -1.98. In the year 1969, what is the difference between the Population growth (in %) of China and Population growth (in %) of Myanmar?
Your answer should be compact. -2.16. In the year 1969, what is the difference between the Population growth (in %) of Maldives and Population growth (in %) of Myanmar?
Offer a terse response. -0.19. What is the ratio of the Population growth (in %) in Belgium in 1962 to that in 1963?
Provide a succinct answer. 0.58. What is the ratio of the Population growth (in %) of China in 1962 to that in 1963?
Provide a succinct answer. 0.71. What is the ratio of the Population growth (in %) in Myanmar in 1962 to that in 1963?
Offer a terse response. 1. What is the ratio of the Population growth (in %) of Belgium in 1962 to that in 1964?
Make the answer very short. 0.48. What is the ratio of the Population growth (in %) of China in 1962 to that in 1964?
Your answer should be compact. 0.73. What is the ratio of the Population growth (in %) of Maldives in 1962 to that in 1964?
Provide a succinct answer. 1.03. What is the ratio of the Population growth (in %) of Myanmar in 1962 to that in 1964?
Your answer should be very brief. 0.98. What is the ratio of the Population growth (in %) in Belgium in 1962 to that in 1965?
Keep it short and to the point. 0.5. What is the ratio of the Population growth (in %) in Maldives in 1962 to that in 1965?
Ensure brevity in your answer.  1.1. What is the ratio of the Population growth (in %) of Myanmar in 1962 to that in 1965?
Offer a very short reply. 0.97. What is the ratio of the Population growth (in %) of Belgium in 1962 to that in 1966?
Your answer should be compact. 0.64. What is the ratio of the Population growth (in %) in China in 1962 to that in 1966?
Make the answer very short. 2.11. What is the ratio of the Population growth (in %) in Maldives in 1962 to that in 1966?
Give a very brief answer. 1.86. What is the ratio of the Population growth (in %) of Myanmar in 1962 to that in 1966?
Your response must be concise. 0.95. What is the ratio of the Population growth (in %) in Belgium in 1962 to that in 1967?
Your answer should be very brief. 0.75. What is the ratio of the Population growth (in %) in China in 1962 to that in 1967?
Your answer should be very brief. 2.1. What is the ratio of the Population growth (in %) in Maldives in 1962 to that in 1967?
Ensure brevity in your answer.  1.92. What is the ratio of the Population growth (in %) of Myanmar in 1962 to that in 1967?
Provide a succinct answer. 0.94. What is the ratio of the Population growth (in %) in Belgium in 1962 to that in 1968?
Ensure brevity in your answer.  0.98. What is the ratio of the Population growth (in %) in China in 1962 to that in 1968?
Offer a very short reply. 2.06. What is the ratio of the Population growth (in %) of Maldives in 1962 to that in 1968?
Your answer should be compact. 0.86. What is the ratio of the Population growth (in %) in Myanmar in 1962 to that in 1968?
Your answer should be very brief. 0.94. What is the ratio of the Population growth (in %) of Belgium in 1962 to that in 1969?
Your answer should be very brief. 1.24. What is the ratio of the Population growth (in %) in China in 1962 to that in 1969?
Make the answer very short. 1.92. What is the ratio of the Population growth (in %) in Maldives in 1962 to that in 1969?
Provide a short and direct response. 0.82. What is the ratio of the Population growth (in %) of Myanmar in 1962 to that in 1969?
Your response must be concise. 0.94. What is the ratio of the Population growth (in %) of Belgium in 1963 to that in 1964?
Keep it short and to the point. 0.82. What is the ratio of the Population growth (in %) of China in 1963 to that in 1964?
Ensure brevity in your answer.  1.03. What is the ratio of the Population growth (in %) of Maldives in 1963 to that in 1964?
Offer a terse response. 1.03. What is the ratio of the Population growth (in %) in Myanmar in 1963 to that in 1964?
Provide a succinct answer. 0.99. What is the ratio of the Population growth (in %) of Belgium in 1963 to that in 1965?
Offer a terse response. 0.86. What is the ratio of the Population growth (in %) of China in 1963 to that in 1965?
Ensure brevity in your answer.  4.54. What is the ratio of the Population growth (in %) in Maldives in 1963 to that in 1965?
Your answer should be very brief. 1.09. What is the ratio of the Population growth (in %) in Myanmar in 1963 to that in 1965?
Make the answer very short. 0.97. What is the ratio of the Population growth (in %) in Belgium in 1963 to that in 1966?
Your answer should be compact. 1.1. What is the ratio of the Population growth (in %) in China in 1963 to that in 1966?
Your response must be concise. 2.99. What is the ratio of the Population growth (in %) in Maldives in 1963 to that in 1966?
Offer a very short reply. 1.85. What is the ratio of the Population growth (in %) of Myanmar in 1963 to that in 1966?
Your response must be concise. 0.96. What is the ratio of the Population growth (in %) of Belgium in 1963 to that in 1967?
Ensure brevity in your answer.  1.29. What is the ratio of the Population growth (in %) in China in 1963 to that in 1967?
Ensure brevity in your answer.  2.98. What is the ratio of the Population growth (in %) of Maldives in 1963 to that in 1967?
Keep it short and to the point. 1.91. What is the ratio of the Population growth (in %) in Myanmar in 1963 to that in 1967?
Make the answer very short. 0.95. What is the ratio of the Population growth (in %) of Belgium in 1963 to that in 1968?
Your response must be concise. 1.68. What is the ratio of the Population growth (in %) in China in 1963 to that in 1968?
Your response must be concise. 2.92. What is the ratio of the Population growth (in %) in Maldives in 1963 to that in 1968?
Make the answer very short. 0.86. What is the ratio of the Population growth (in %) in Myanmar in 1963 to that in 1968?
Offer a terse response. 0.94. What is the ratio of the Population growth (in %) in Belgium in 1963 to that in 1969?
Keep it short and to the point. 2.13. What is the ratio of the Population growth (in %) in China in 1963 to that in 1969?
Your answer should be very brief. 2.73. What is the ratio of the Population growth (in %) of Maldives in 1963 to that in 1969?
Provide a succinct answer. 0.82. What is the ratio of the Population growth (in %) in Myanmar in 1963 to that in 1969?
Keep it short and to the point. 0.94. What is the ratio of the Population growth (in %) in Belgium in 1964 to that in 1965?
Your response must be concise. 1.04. What is the ratio of the Population growth (in %) of China in 1964 to that in 1965?
Make the answer very short. 4.4. What is the ratio of the Population growth (in %) of Maldives in 1964 to that in 1965?
Provide a succinct answer. 1.06. What is the ratio of the Population growth (in %) in Myanmar in 1964 to that in 1965?
Provide a succinct answer. 0.99. What is the ratio of the Population growth (in %) of Belgium in 1964 to that in 1966?
Your answer should be compact. 1.33. What is the ratio of the Population growth (in %) in China in 1964 to that in 1966?
Offer a very short reply. 2.9. What is the ratio of the Population growth (in %) of Maldives in 1964 to that in 1966?
Offer a very short reply. 1.8. What is the ratio of the Population growth (in %) of Myanmar in 1964 to that in 1966?
Give a very brief answer. 0.97. What is the ratio of the Population growth (in %) in Belgium in 1964 to that in 1967?
Provide a short and direct response. 1.56. What is the ratio of the Population growth (in %) of China in 1964 to that in 1967?
Offer a very short reply. 2.89. What is the ratio of the Population growth (in %) in Maldives in 1964 to that in 1967?
Your response must be concise. 1.86. What is the ratio of the Population growth (in %) of Myanmar in 1964 to that in 1967?
Your answer should be compact. 0.96. What is the ratio of the Population growth (in %) of Belgium in 1964 to that in 1968?
Keep it short and to the point. 2.04. What is the ratio of the Population growth (in %) in China in 1964 to that in 1968?
Ensure brevity in your answer.  2.83. What is the ratio of the Population growth (in %) in Maldives in 1964 to that in 1968?
Keep it short and to the point. 0.83. What is the ratio of the Population growth (in %) of Myanmar in 1964 to that in 1968?
Provide a short and direct response. 0.95. What is the ratio of the Population growth (in %) in Belgium in 1964 to that in 1969?
Offer a terse response. 2.58. What is the ratio of the Population growth (in %) in China in 1964 to that in 1969?
Provide a succinct answer. 2.65. What is the ratio of the Population growth (in %) in Maldives in 1964 to that in 1969?
Your response must be concise. 0.79. What is the ratio of the Population growth (in %) in Myanmar in 1964 to that in 1969?
Your answer should be compact. 0.96. What is the ratio of the Population growth (in %) in Belgium in 1965 to that in 1966?
Your answer should be compact. 1.28. What is the ratio of the Population growth (in %) of China in 1965 to that in 1966?
Offer a very short reply. 0.66. What is the ratio of the Population growth (in %) in Maldives in 1965 to that in 1966?
Give a very brief answer. 1.7. What is the ratio of the Population growth (in %) in Myanmar in 1965 to that in 1966?
Your answer should be very brief. 0.98. What is the ratio of the Population growth (in %) of Belgium in 1965 to that in 1967?
Your answer should be compact. 1.5. What is the ratio of the Population growth (in %) of China in 1965 to that in 1967?
Your answer should be compact. 0.66. What is the ratio of the Population growth (in %) of Maldives in 1965 to that in 1967?
Make the answer very short. 1.75. What is the ratio of the Population growth (in %) of Myanmar in 1965 to that in 1967?
Make the answer very short. 0.97. What is the ratio of the Population growth (in %) in Belgium in 1965 to that in 1968?
Make the answer very short. 1.96. What is the ratio of the Population growth (in %) of China in 1965 to that in 1968?
Give a very brief answer. 0.64. What is the ratio of the Population growth (in %) of Maldives in 1965 to that in 1968?
Ensure brevity in your answer.  0.79. What is the ratio of the Population growth (in %) of Myanmar in 1965 to that in 1968?
Your answer should be very brief. 0.97. What is the ratio of the Population growth (in %) in Belgium in 1965 to that in 1969?
Provide a succinct answer. 2.48. What is the ratio of the Population growth (in %) of China in 1965 to that in 1969?
Provide a short and direct response. 0.6. What is the ratio of the Population growth (in %) in Maldives in 1965 to that in 1969?
Ensure brevity in your answer.  0.75. What is the ratio of the Population growth (in %) in Myanmar in 1965 to that in 1969?
Provide a succinct answer. 0.97. What is the ratio of the Population growth (in %) in Belgium in 1966 to that in 1967?
Provide a short and direct response. 1.17. What is the ratio of the Population growth (in %) of China in 1966 to that in 1967?
Provide a succinct answer. 1. What is the ratio of the Population growth (in %) in Maldives in 1966 to that in 1967?
Give a very brief answer. 1.03. What is the ratio of the Population growth (in %) in Belgium in 1966 to that in 1968?
Offer a terse response. 1.53. What is the ratio of the Population growth (in %) of China in 1966 to that in 1968?
Ensure brevity in your answer.  0.98. What is the ratio of the Population growth (in %) of Maldives in 1966 to that in 1968?
Provide a short and direct response. 0.46. What is the ratio of the Population growth (in %) of Myanmar in 1966 to that in 1968?
Offer a terse response. 0.98. What is the ratio of the Population growth (in %) in Belgium in 1966 to that in 1969?
Offer a very short reply. 1.94. What is the ratio of the Population growth (in %) in Maldives in 1966 to that in 1969?
Give a very brief answer. 0.44. What is the ratio of the Population growth (in %) of Myanmar in 1966 to that in 1969?
Keep it short and to the point. 0.99. What is the ratio of the Population growth (in %) in Belgium in 1967 to that in 1968?
Make the answer very short. 1.31. What is the ratio of the Population growth (in %) of China in 1967 to that in 1968?
Keep it short and to the point. 0.98. What is the ratio of the Population growth (in %) of Maldives in 1967 to that in 1968?
Your response must be concise. 0.45. What is the ratio of the Population growth (in %) in Belgium in 1967 to that in 1969?
Your answer should be compact. 1.65. What is the ratio of the Population growth (in %) of China in 1967 to that in 1969?
Offer a terse response. 0.92. What is the ratio of the Population growth (in %) in Maldives in 1967 to that in 1969?
Your response must be concise. 0.43. What is the ratio of the Population growth (in %) of Belgium in 1968 to that in 1969?
Provide a succinct answer. 1.26. What is the ratio of the Population growth (in %) of China in 1968 to that in 1969?
Offer a very short reply. 0.94. What is the ratio of the Population growth (in %) of Maldives in 1968 to that in 1969?
Give a very brief answer. 0.95. What is the ratio of the Population growth (in %) of Myanmar in 1968 to that in 1969?
Your answer should be compact. 1. What is the difference between the highest and the second highest Population growth (in %) in Belgium?
Ensure brevity in your answer.  0.04. What is the difference between the highest and the second highest Population growth (in %) of China?
Your response must be concise. 0.17. What is the difference between the highest and the second highest Population growth (in %) in Maldives?
Offer a terse response. 0.2. What is the difference between the highest and the lowest Population growth (in %) of Belgium?
Your answer should be very brief. 0.68. What is the difference between the highest and the lowest Population growth (in %) in China?
Your answer should be compact. 4.28. What is the difference between the highest and the lowest Population growth (in %) in Maldives?
Keep it short and to the point. 2.28. What is the difference between the highest and the lowest Population growth (in %) in Myanmar?
Your response must be concise. 0.26. 